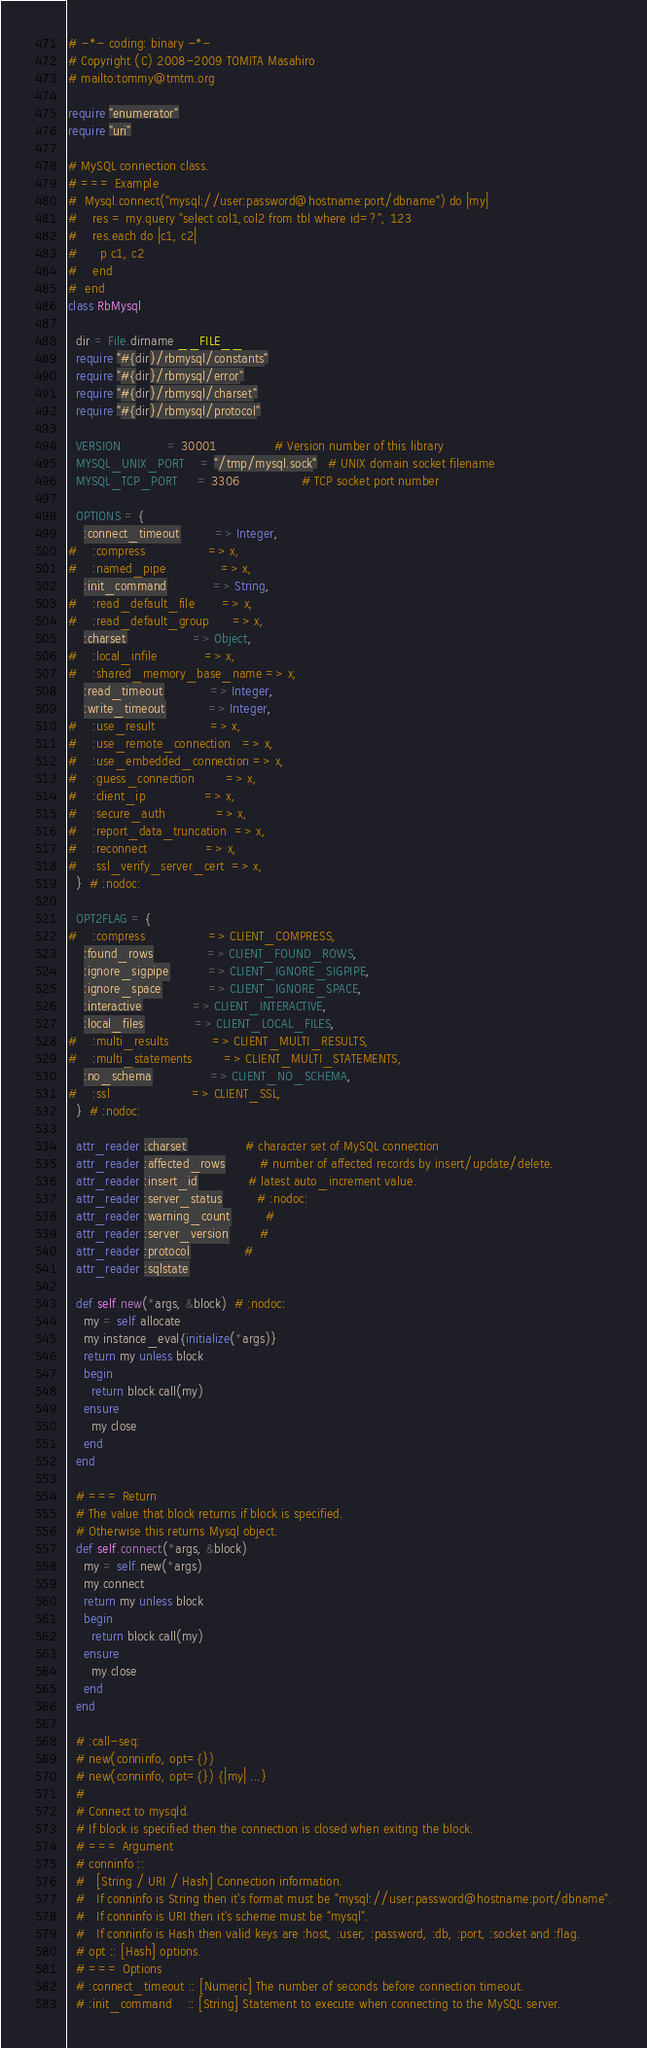Convert code to text. <code><loc_0><loc_0><loc_500><loc_500><_Ruby_># -*- coding: binary -*-
# Copyright (C) 2008-2009 TOMITA Masahiro
# mailto:tommy@tmtm.org

require "enumerator"
require "uri"

# MySQL connection class.
# === Example
#  Mysql.connect("mysql://user:password@hostname:port/dbname") do |my|
#    res = my.query "select col1,col2 from tbl where id=?", 123
#    res.each do |c1, c2|
#      p c1, c2
#    end
#  end
class RbMysql

  dir = File.dirname __FILE__
  require "#{dir}/rbmysql/constants"
  require "#{dir}/rbmysql/error"
  require "#{dir}/rbmysql/charset"
  require "#{dir}/rbmysql/protocol"

  VERSION            = 30001               # Version number of this library
  MYSQL_UNIX_PORT    = "/tmp/mysql.sock"   # UNIX domain socket filename
  MYSQL_TCP_PORT     = 3306                # TCP socket port number

  OPTIONS = {
    :connect_timeout         => Integer,
#    :compress                => x,
#    :named_pipe              => x,
    :init_command            => String,
#    :read_default_file       => x,
#    :read_default_group      => x,
    :charset                 => Object,
#    :local_infile            => x,
#    :shared_memory_base_name => x,
    :read_timeout            => Integer,
    :write_timeout           => Integer,
#    :use_result              => x,
#    :use_remote_connection   => x,
#    :use_embedded_connection => x,
#    :guess_connection        => x,
#    :client_ip               => x,
#    :secure_auth             => x,
#    :report_data_truncation  => x,
#    :reconnect               => x,
#    :ssl_verify_server_cert  => x,
  }  # :nodoc:

  OPT2FLAG = {
#    :compress                => CLIENT_COMPRESS,
    :found_rows              => CLIENT_FOUND_ROWS,
    :ignore_sigpipe          => CLIENT_IGNORE_SIGPIPE,
    :ignore_space            => CLIENT_IGNORE_SPACE,
    :interactive             => CLIENT_INTERACTIVE,
    :local_files             => CLIENT_LOCAL_FILES,
#    :multi_results           => CLIENT_MULTI_RESULTS,
#    :multi_statements        => CLIENT_MULTI_STATEMENTS,
    :no_schema               => CLIENT_NO_SCHEMA,
#    :ssl                     => CLIENT_SSL,
  }  # :nodoc:

  attr_reader :charset               # character set of MySQL connection
  attr_reader :affected_rows         # number of affected records by insert/update/delete.
  attr_reader :insert_id             # latest auto_increment value.
  attr_reader :server_status         # :nodoc:
  attr_reader :warning_count         #
  attr_reader :server_version        #
  attr_reader :protocol              #
  attr_reader :sqlstate

  def self.new(*args, &block)  # :nodoc:
    my = self.allocate
    my.instance_eval{initialize(*args)}
    return my unless block
    begin
      return block.call(my)
    ensure
      my.close
    end
  end

  # === Return
  # The value that block returns if block is specified.
  # Otherwise this returns Mysql object.
  def self.connect(*args, &block)
    my = self.new(*args)
    my.connect
    return my unless block
    begin
      return block.call(my)
    ensure
      my.close
    end
  end

  # :call-seq:
  # new(conninfo, opt={})
  # new(conninfo, opt={}) {|my| ...}
  #
  # Connect to mysqld.
  # If block is specified then the connection is closed when exiting the block.
  # === Argument
  # conninfo ::
  #   [String / URI / Hash] Connection information.
  #   If conninfo is String then it's format must be "mysql://user:password@hostname:port/dbname".
  #   If conninfo is URI then it's scheme must be "mysql".
  #   If conninfo is Hash then valid keys are :host, :user, :password, :db, :port, :socket and :flag.
  # opt :: [Hash] options.
  # === Options
  # :connect_timeout :: [Numeric] The number of seconds before connection timeout.
  # :init_command    :: [String] Statement to execute when connecting to the MySQL server.</code> 